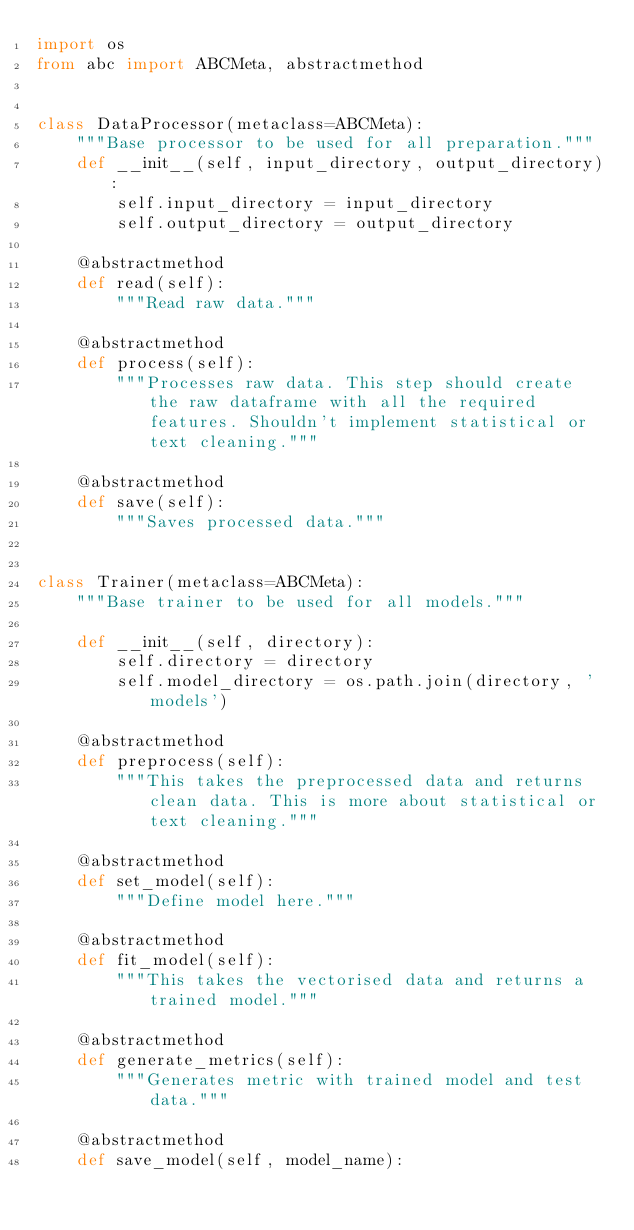Convert code to text. <code><loc_0><loc_0><loc_500><loc_500><_Python_>import os
from abc import ABCMeta, abstractmethod


class DataProcessor(metaclass=ABCMeta):
    """Base processor to be used for all preparation."""
    def __init__(self, input_directory, output_directory):
        self.input_directory = input_directory
        self.output_directory = output_directory

    @abstractmethod
    def read(self):
        """Read raw data."""

    @abstractmethod
    def process(self):
        """Processes raw data. This step should create the raw dataframe with all the required features. Shouldn't implement statistical or text cleaning."""

    @abstractmethod
    def save(self):
        """Saves processed data."""


class Trainer(metaclass=ABCMeta):
    """Base trainer to be used for all models."""

    def __init__(self, directory):
        self.directory = directory
        self.model_directory = os.path.join(directory, 'models')

    @abstractmethod
    def preprocess(self):
        """This takes the preprocessed data and returns clean data. This is more about statistical or text cleaning."""

    @abstractmethod
    def set_model(self):
        """Define model here."""

    @abstractmethod
    def fit_model(self):
        """This takes the vectorised data and returns a trained model."""

    @abstractmethod
    def generate_metrics(self):
        """Generates metric with trained model and test data."""

    @abstractmethod
    def save_model(self, model_name):</code> 